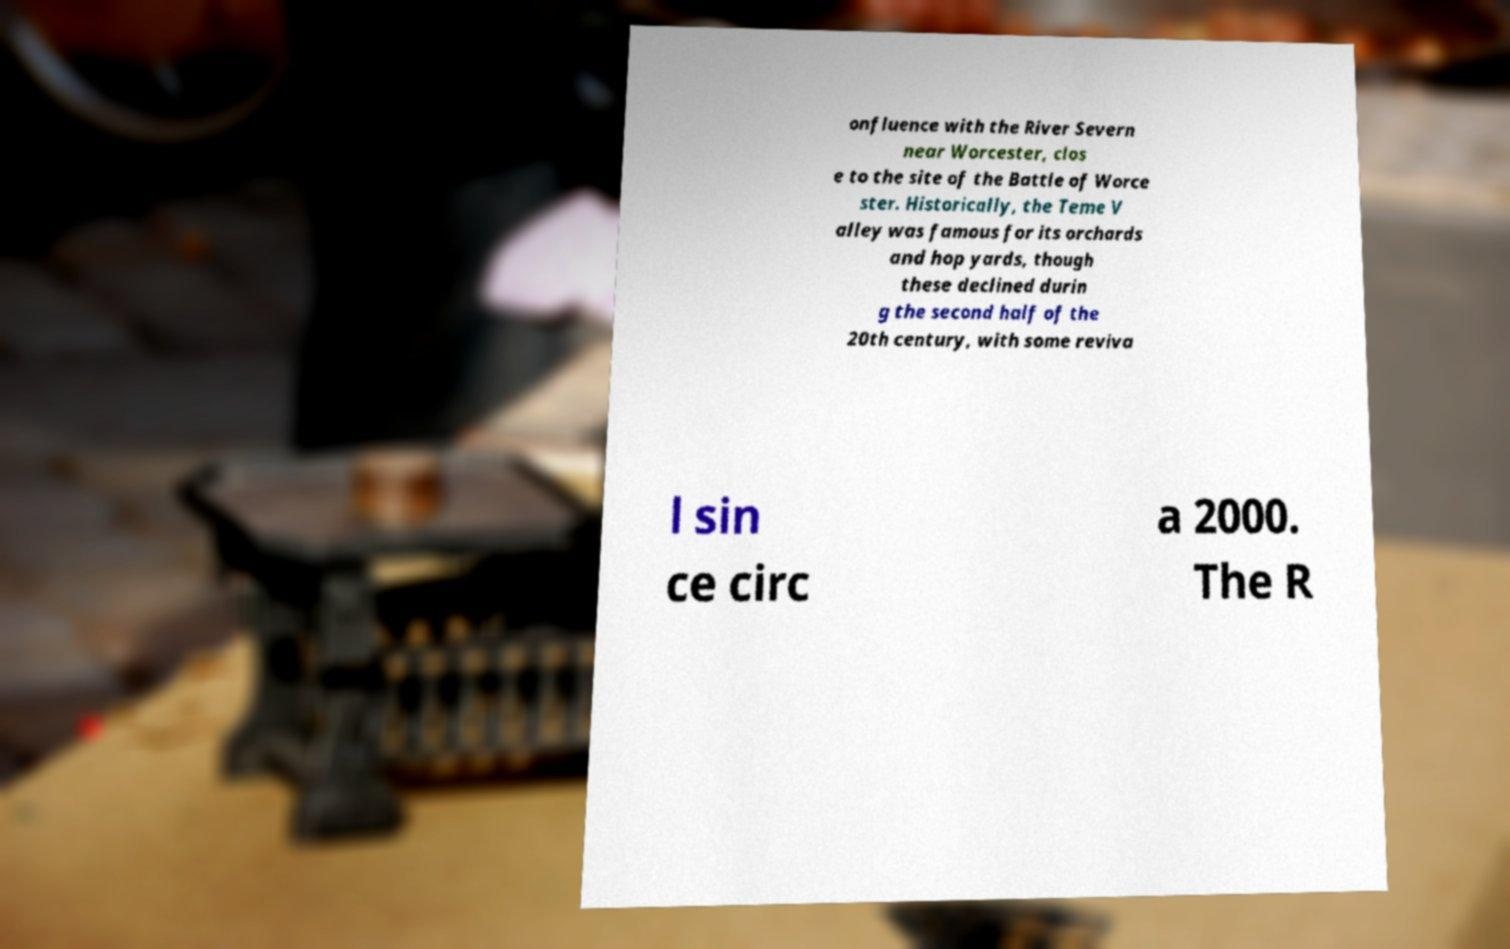Please identify and transcribe the text found in this image. onfluence with the River Severn near Worcester, clos e to the site of the Battle of Worce ster. Historically, the Teme V alley was famous for its orchards and hop yards, though these declined durin g the second half of the 20th century, with some reviva l sin ce circ a 2000. The R 